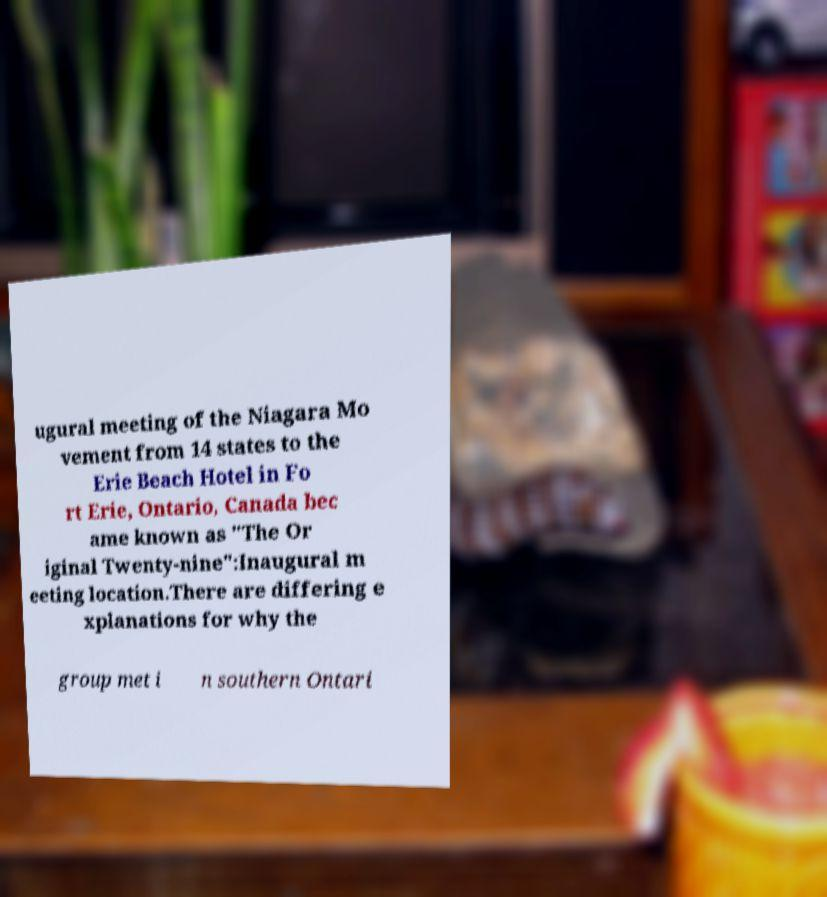For documentation purposes, I need the text within this image transcribed. Could you provide that? ugural meeting of the Niagara Mo vement from 14 states to the Erie Beach Hotel in Fo rt Erie, Ontario, Canada bec ame known as "The Or iginal Twenty-nine":Inaugural m eeting location.There are differing e xplanations for why the group met i n southern Ontari 